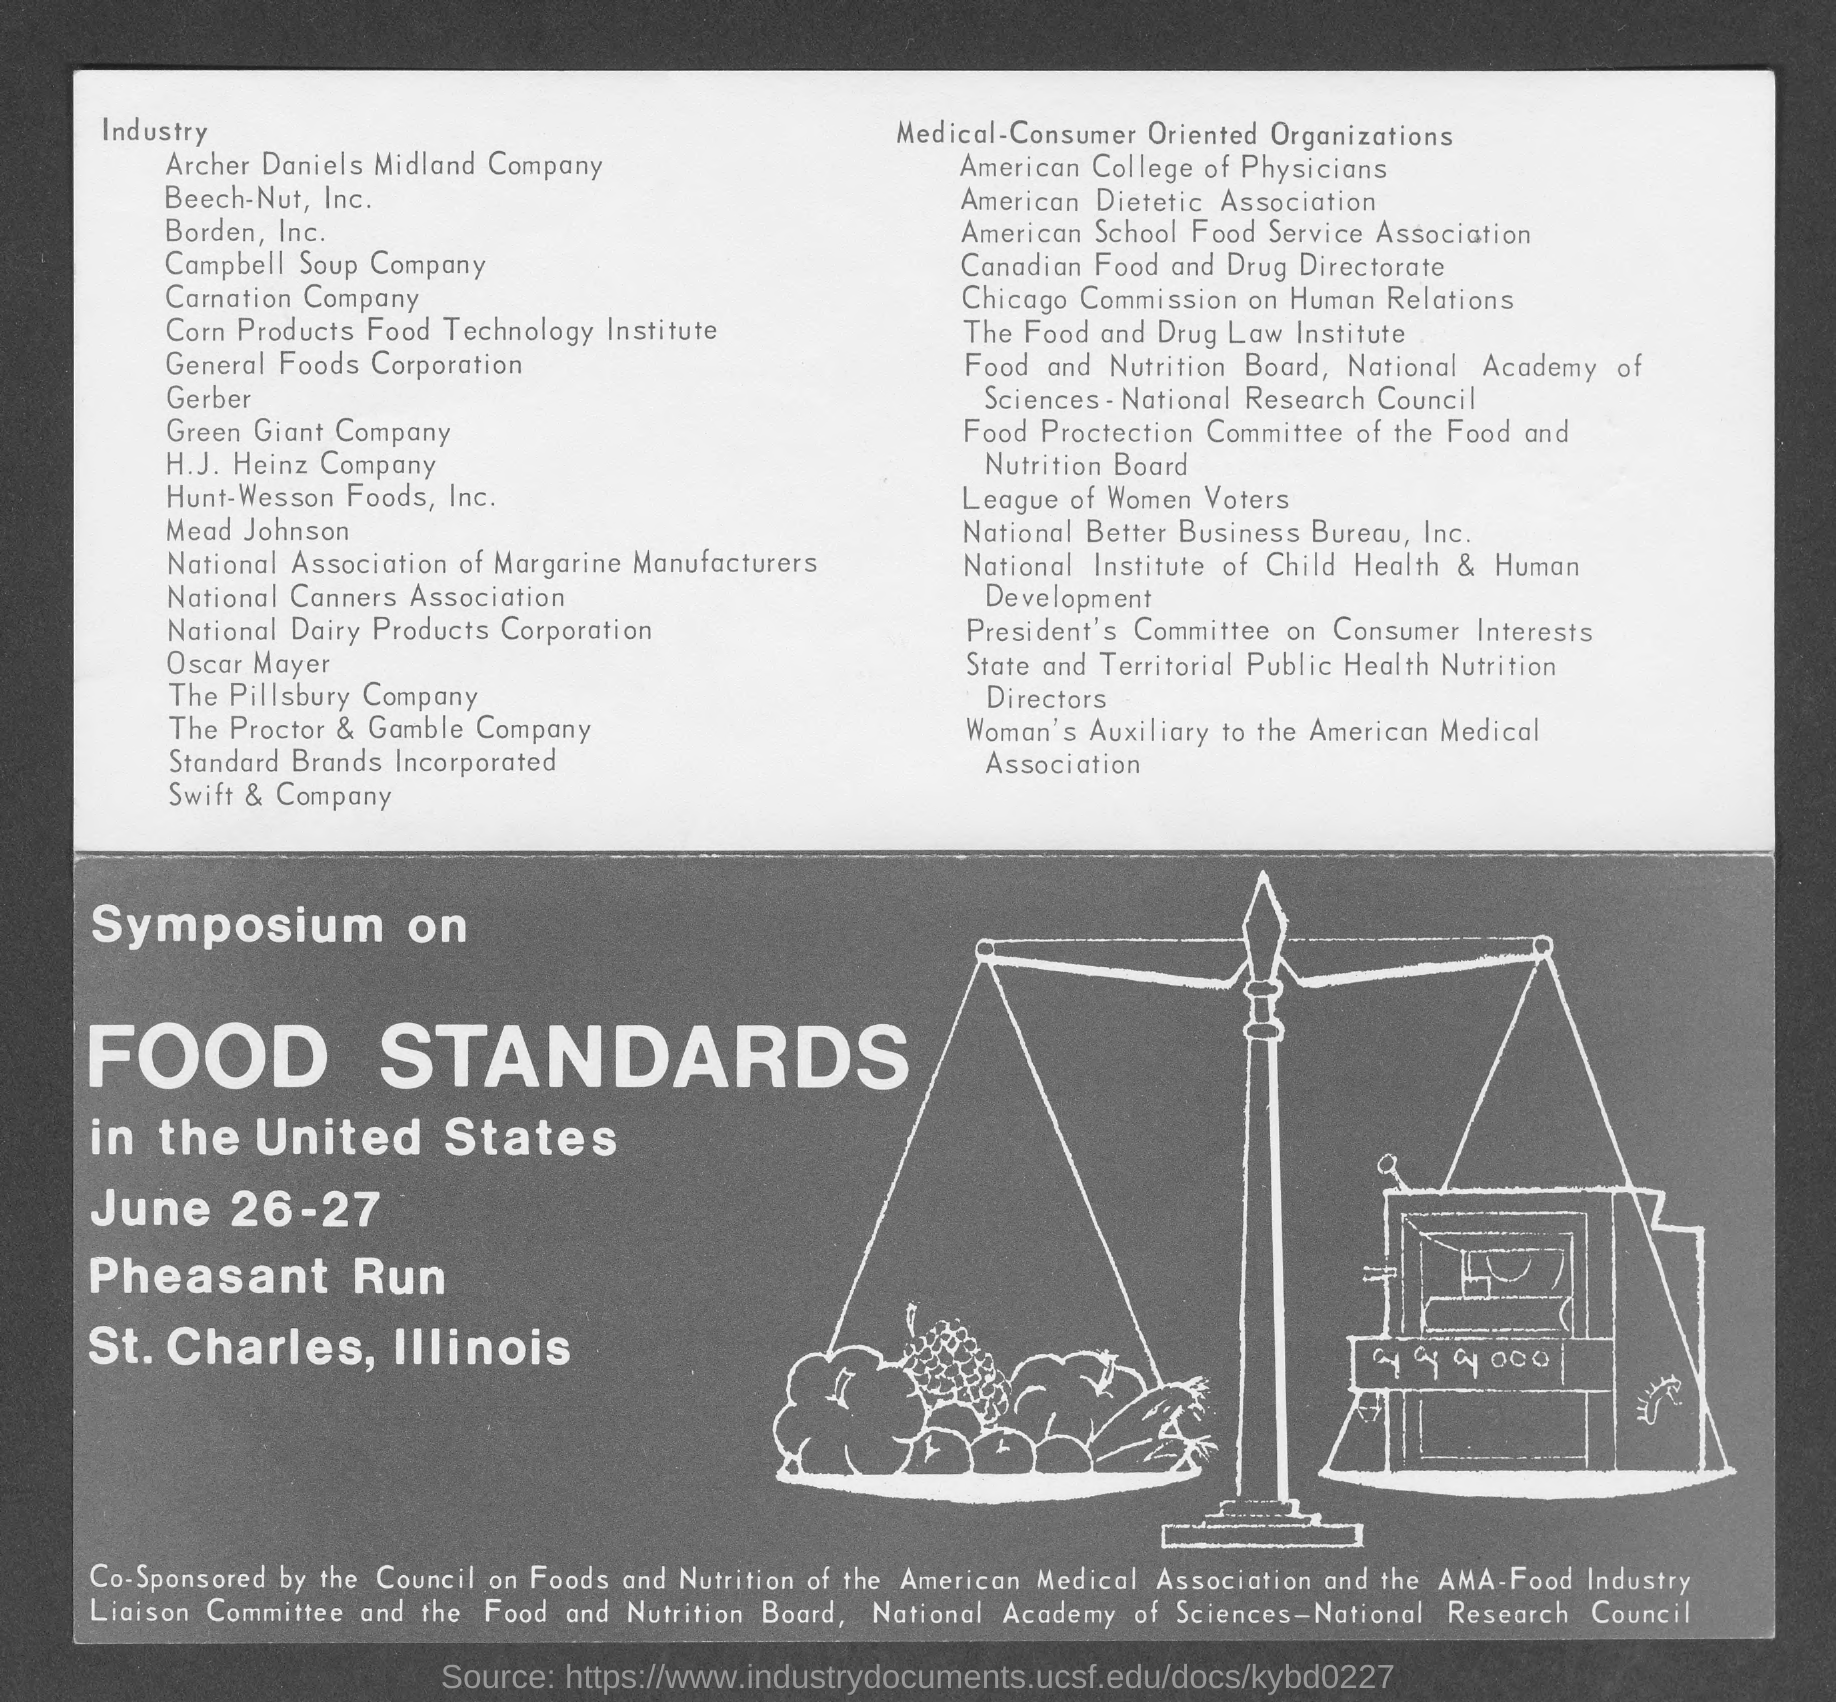Highlight a few significant elements in this photo. The Symposium on Food Standards will be held on June 26-27. 